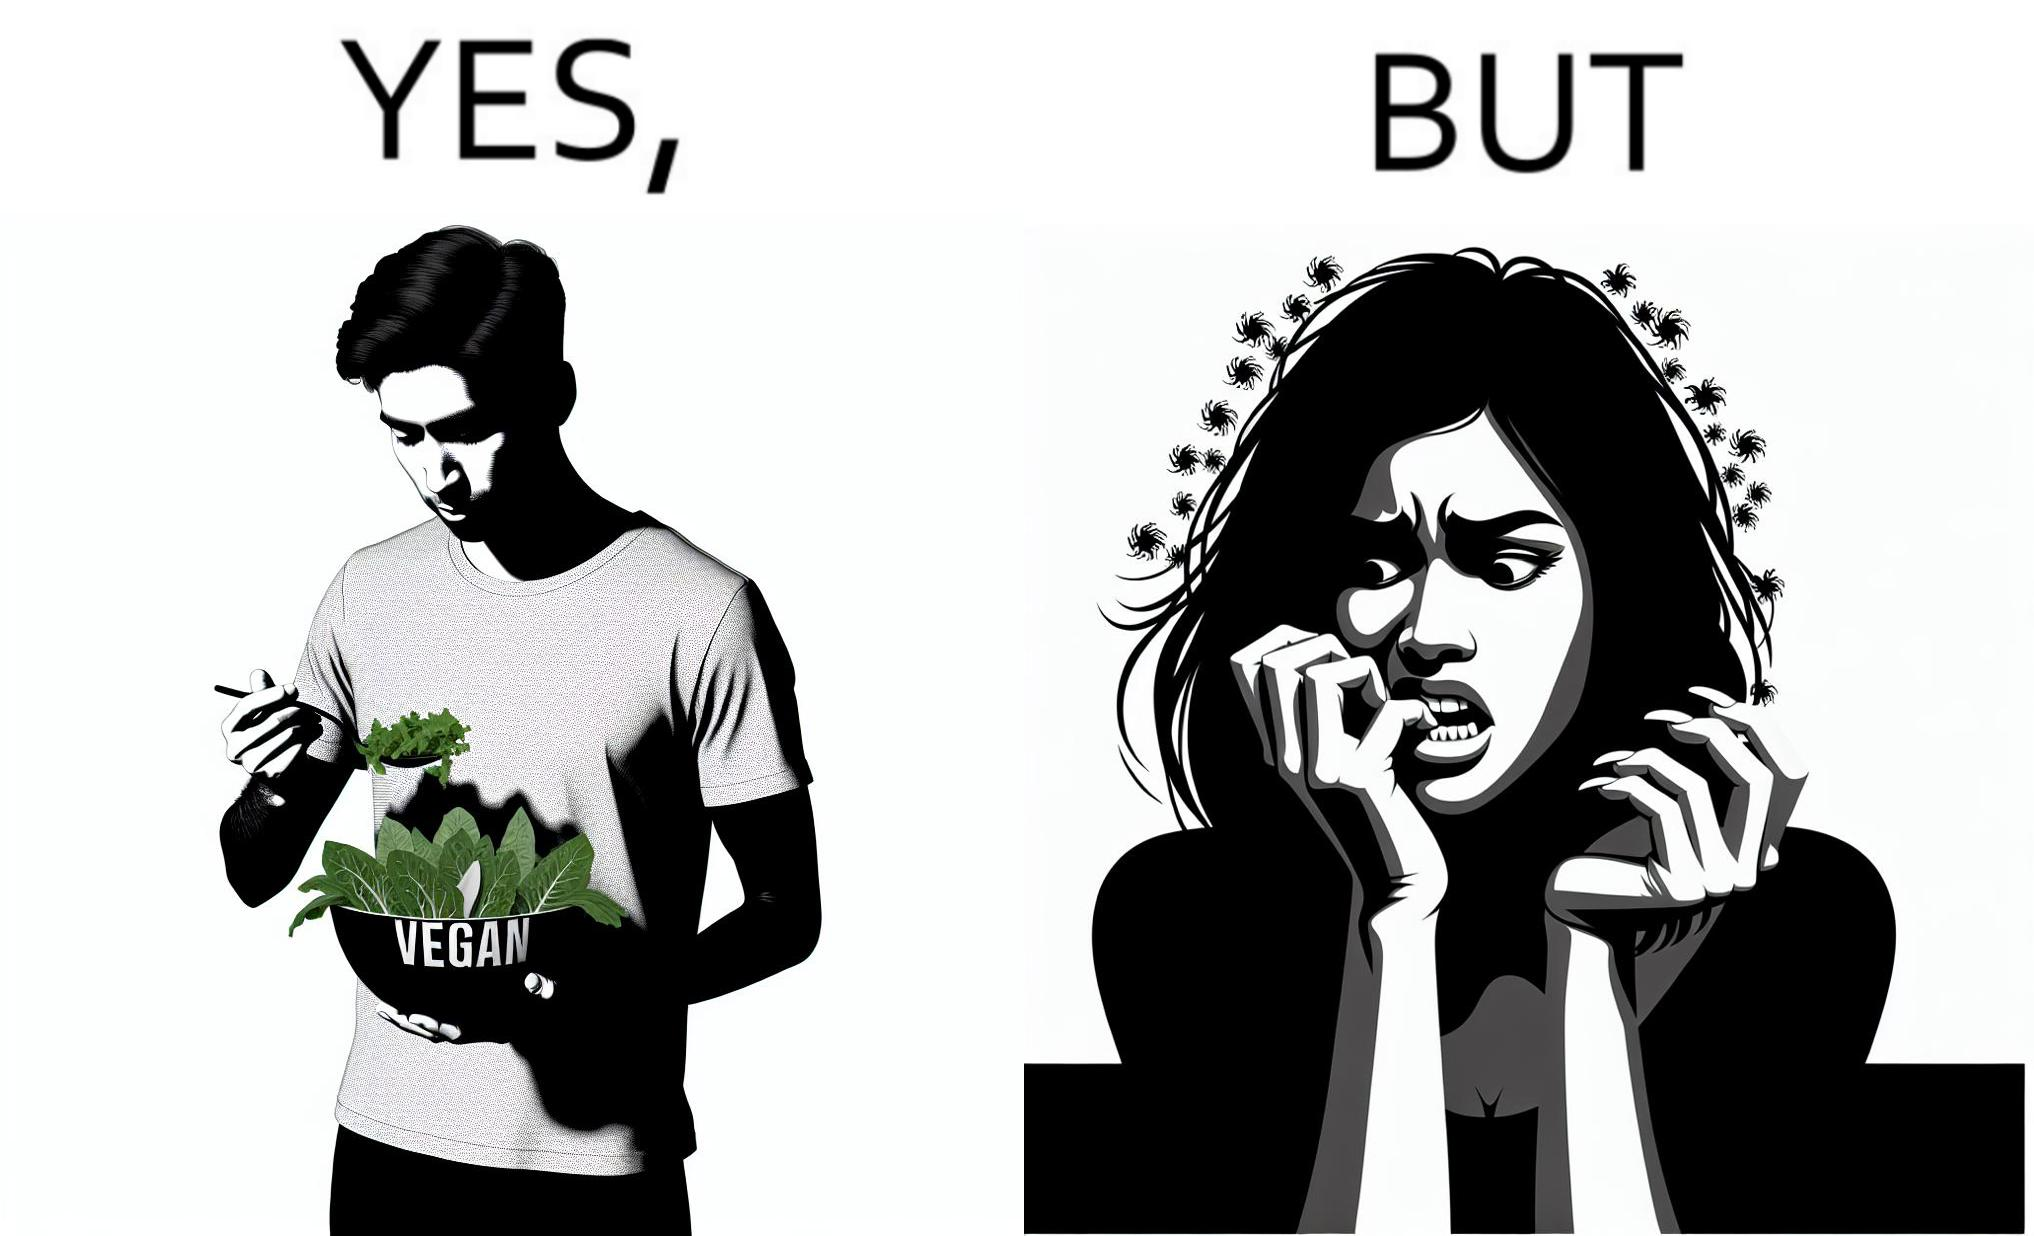What is the satirical meaning behind this image? The image is funny because while the man claims to be vegan, he is biting skin off his own hand. 